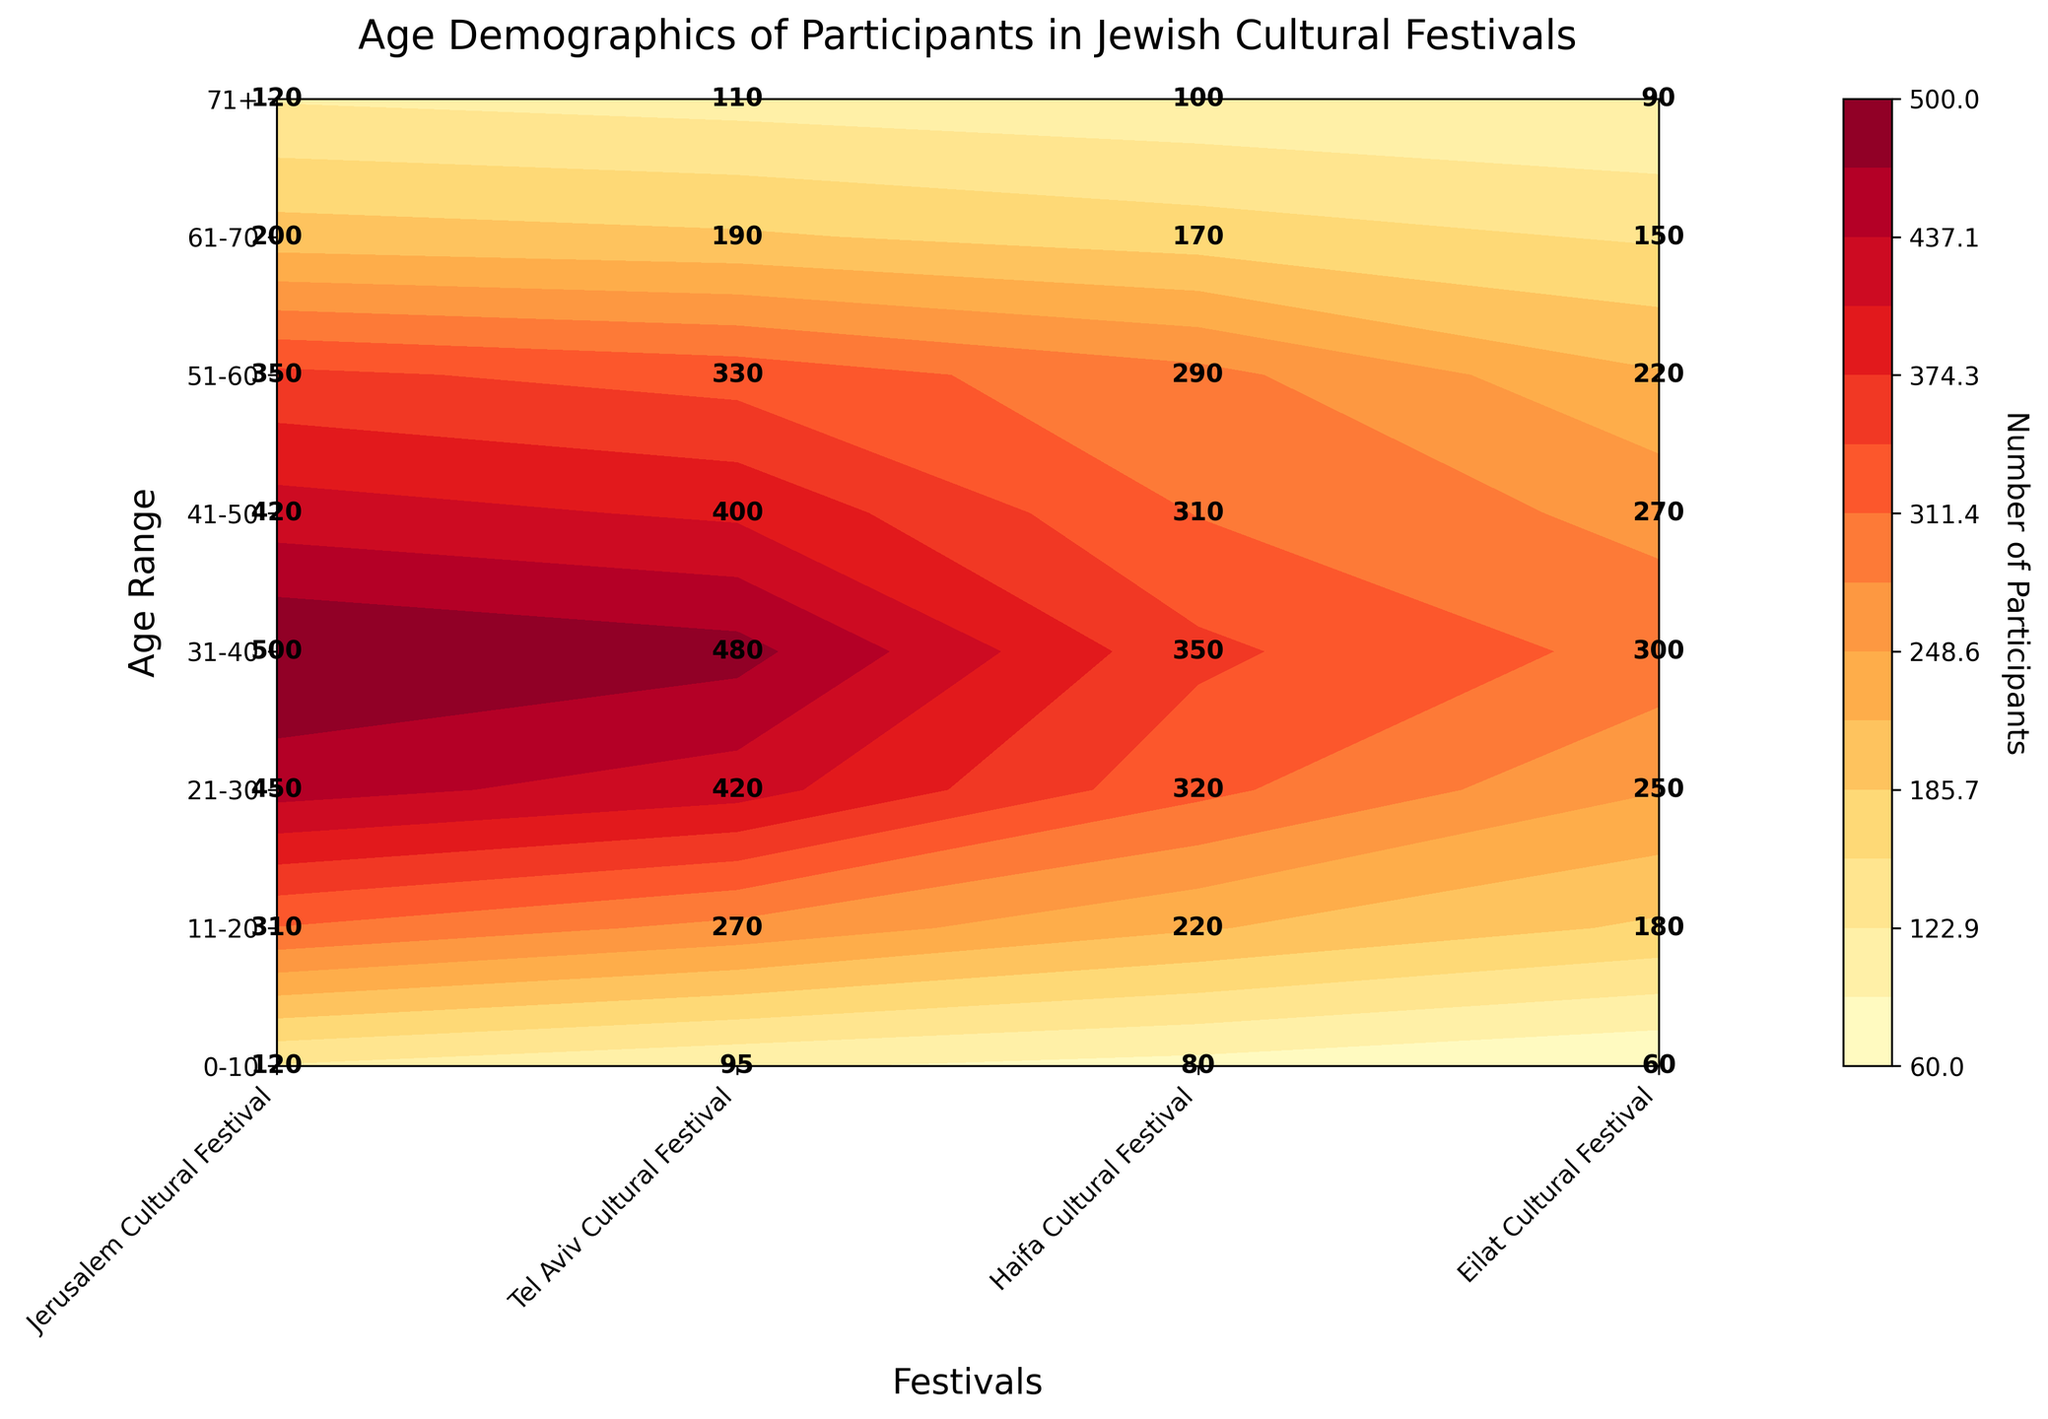What is the title of the figure? The title of the figure is located at the top and is used to provide a brief description of what the figure represents.
Answer: Age Demographics of Participants in Jewish Cultural Festivals How many age groups are represented in the figure? The number of age groups can be counted from the labels on the y-axis.
Answer: 8 Which festival has the highest number of participants in the 21-30 age range? The contour plot includes the number of participants for each combination of age range and festival. Find the 21-30 age range and identify which festival has the highest value in that row.
Answer: Jerusalem Cultural Festival In the age range 41-50, compare the number of participants between Haifa and Eilat. Locate the 41-50 age range on the y-axis and then compare the corresponding values on the x-axis for Haifa and Eilat.
Answer: Haifa has 310 and Eilat has 270 participants What is the average number of participants for the Eilat Cultural Festival across all age ranges? Sum the number of participants for Eilat Cultural Festival across all age ranges and divide by the number of age ranges. The values are: 60 + 180 + 250 + 300 + 270 + 220 + 150 + 90. Sum = 1520; Average = 1520 / 8 = 190.
Answer: 190 Which age group has the lowest number of participants for the Tel Aviv Cultural Festival? Find the minimum value in the column for the Tel Aviv Cultural Festival by looking down the corresponding row labels on the y-axis.
Answer: 71+ What is the total number of participants aged 51-60 across all festivals? Sum the number of participants from all festivals for the 51-60 age range. The values are: 350 (Jerusalem) + 330 (Tel Aviv) + 290 (Haifa) + 220 (Eilat). Sum = 1190.
Answer: 1190 Compare the total number of participants in the 0-10 and 61-70 age ranges. Which one has more participants? Sum the number of participants across all festivals for both age ranges and then compare the totals. 0-10: 120 + 95 + 80 + 60 = 355. 61-70: 200 + 190 + 170 + 150 = 710. 61-70 has more participants.
Answer: 61-70 Which festival has the most evenly distributed participant numbers across all age groups? Examine the values across age groups for each festival and identify the festival whose participant numbers vary the least.
Answer: Tel Aviv Cultural Festival 